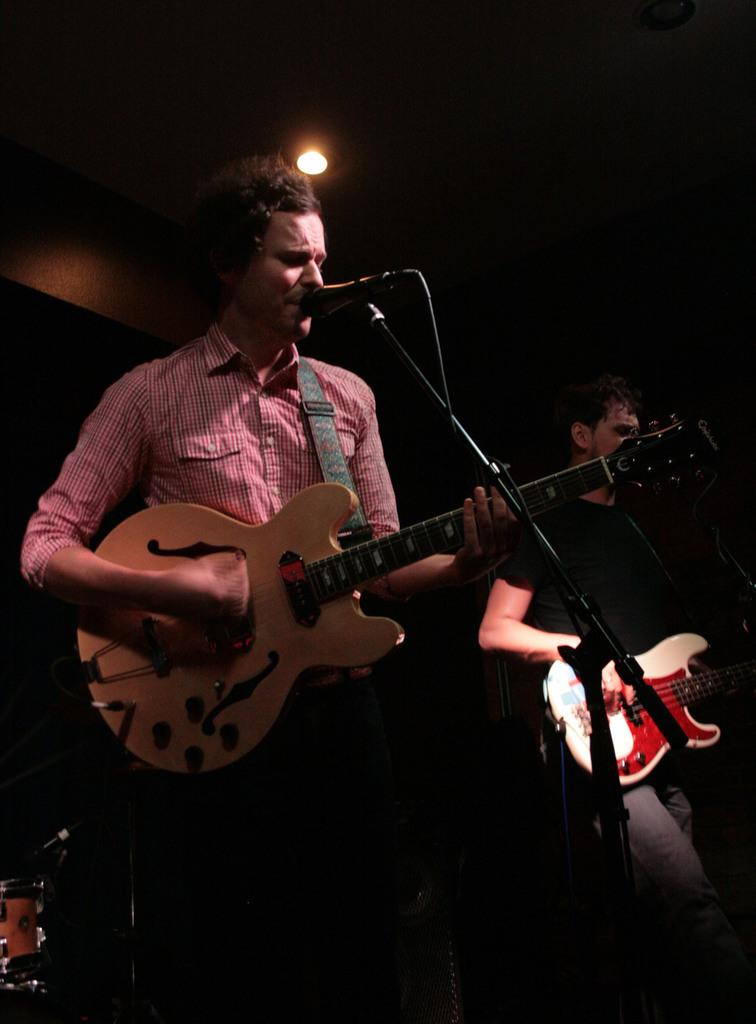What is the person in the pink shirt doing in the image? The person is playing a guitar and singing. What object is the person using to amplify their voice? There is a microphone in the image. Is there anyone else in the image? Yes, there is another person in the image. What is the second person doing? The second person is also playing a guitar. What type of plantation can be seen in the background of the image? There is no plantation visible in the image. How many hands does the person in the pink shirt have? The person in the pink shirt has two hands, just like any other person. 